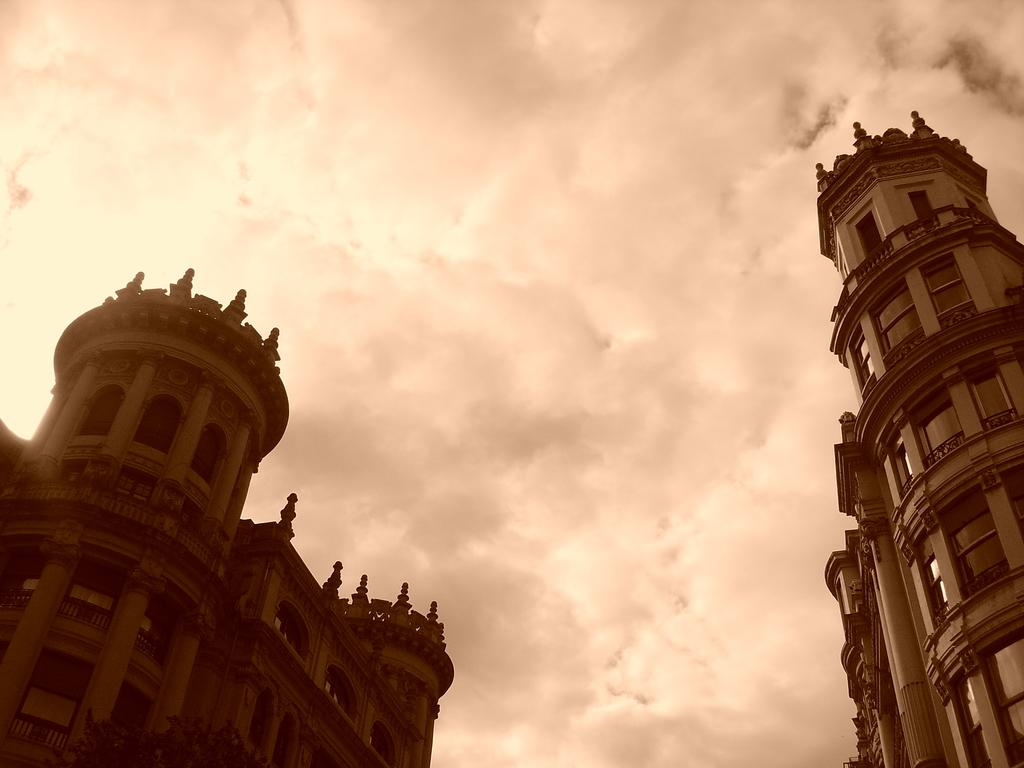What type of structures are in the image? There are two historical construction buildings in the image. What features do the buildings have? The buildings have windows and designs on them. What can be seen in the background of the image? There is a sky visible in the background of the image. What is the weather like in the image? Clouds are present in the sky, suggesting a partly cloudy day. How many pets are visible in the image? There are no pets present in the image; it features historical construction buildings and a sky with clouds. Are there any tomatoes growing on the buildings in the image? There are no tomatoes visible in the image; the buildings have designs on them, but no plants or fruits are depicted. 